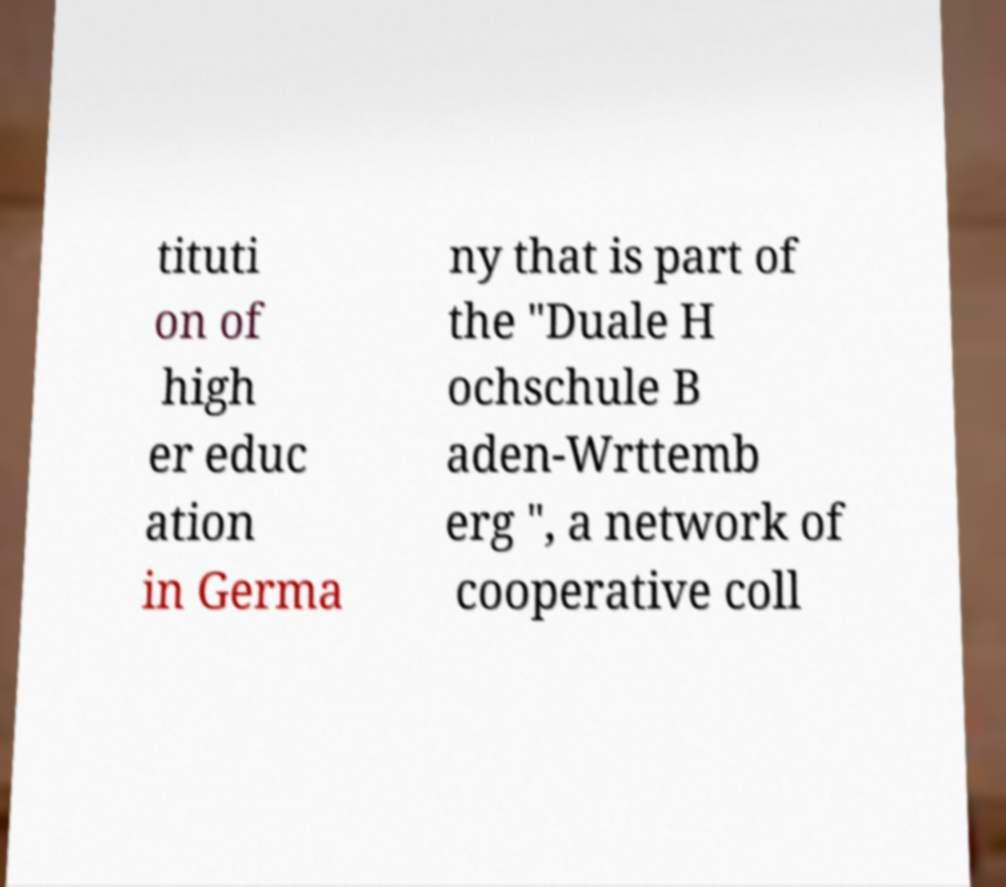Can you read and provide the text displayed in the image?This photo seems to have some interesting text. Can you extract and type it out for me? tituti on of high er educ ation in Germa ny that is part of the "Duale H ochschule B aden-Wrttemb erg ", a network of cooperative coll 